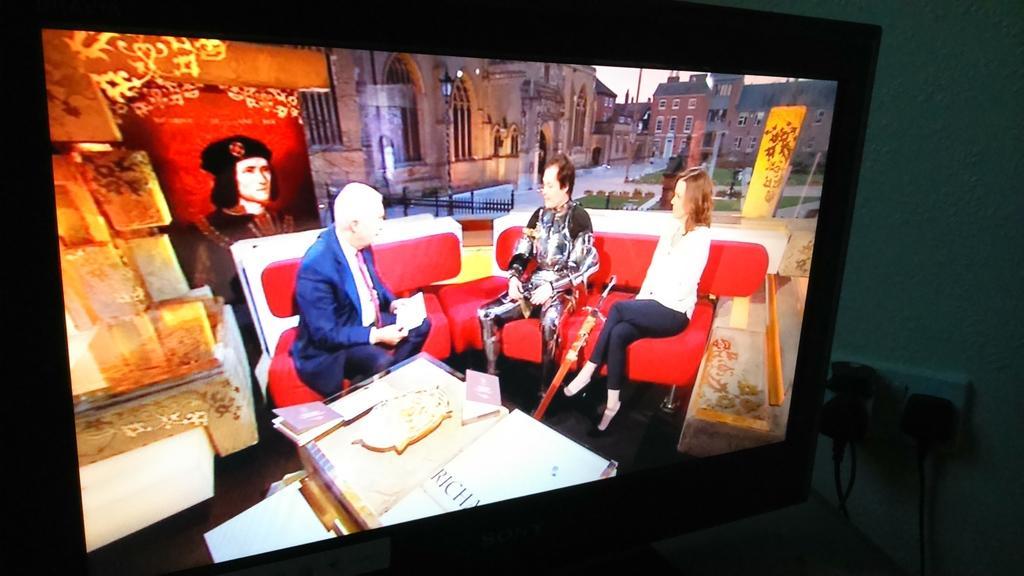Can you describe this image briefly? In this picture we can see a television, in the television we can see few buildings and group of people, in front of them we can see few books on the table, on the right side of the image we can see a socket and few cables. 